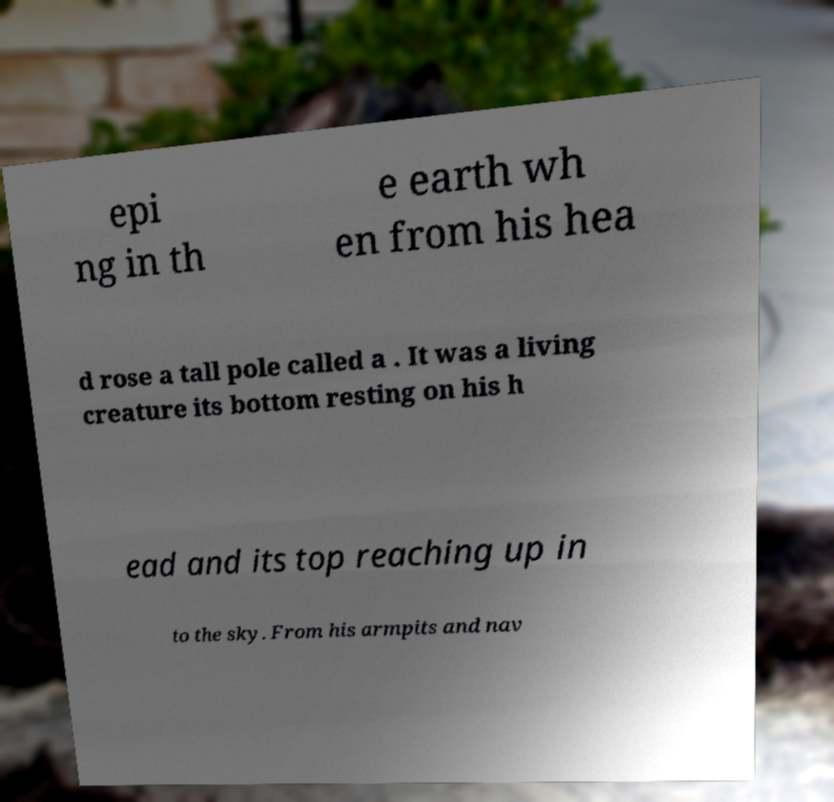Can you accurately transcribe the text from the provided image for me? epi ng in th e earth wh en from his hea d rose a tall pole called a . It was a living creature its bottom resting on his h ead and its top reaching up in to the sky. From his armpits and nav 